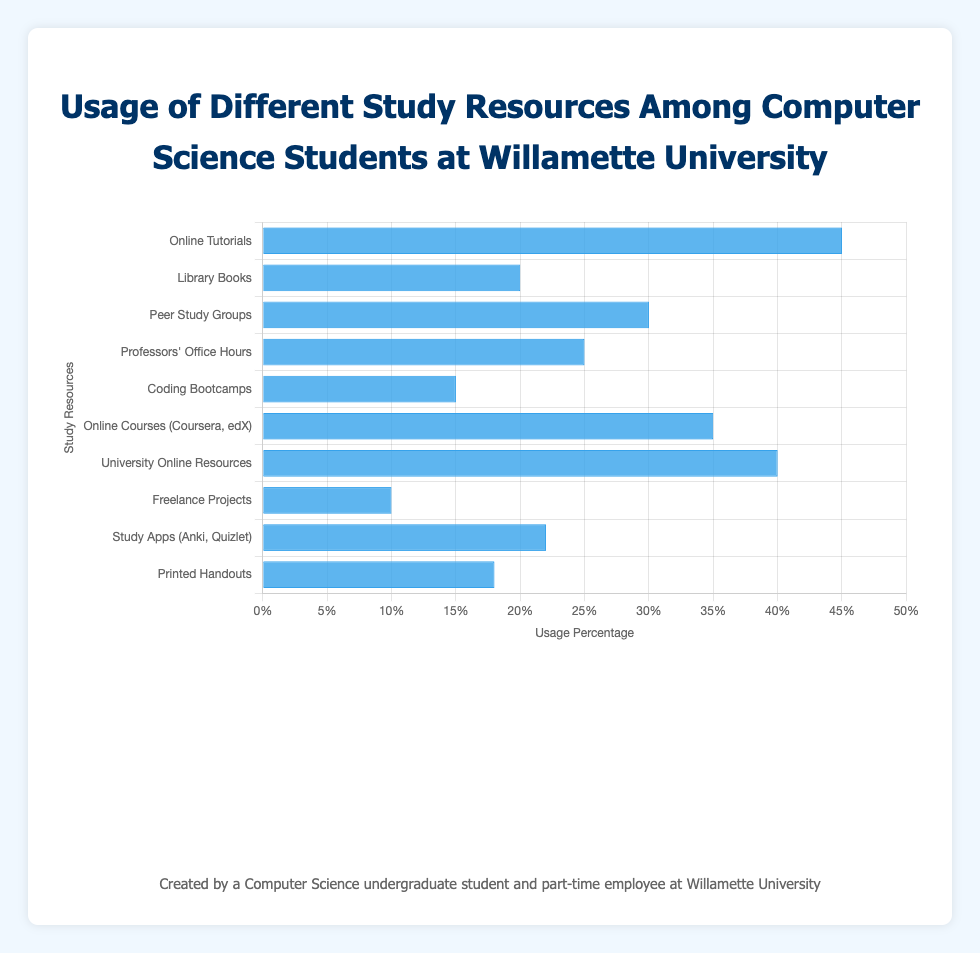What's the most frequently used study resource among Computer Science students according to the chart? The highest bar represents "Online Tutorials" with a usage percentage of 45%. It is the most frequently used study resource among students.
Answer: Online Tutorials Which study resource has the lowest usage percentage? The shortest bar represents "Freelance Projects" with a usage percentage of 10%. Therefore, it denotes the least utilized study resource.
Answer: Freelance Projects How much higher is the usage percentage of "Online Courses (Coursera, edX)" compared to "Coding Bootcamps"? To find this, subtract the usage percentage of "Coding Bootcamps" (15%) from "Online Courses (Coursera, edX)" (35%). The difference is 35% - 15% = 20%.
Answer: 20% What is the sum of the usage percentages for "Library Books" and "Professors' Office Hours"? Add the usage percentages of "Library Books" (20%) and "Professors' Office Hours" (25%). The total is 20% + 25% = 45%.
Answer: 45% Which is used more by students, "Peer Study Groups" or "University Online Resources (Blackboard, Moodle)"? And by how much? "Peer Study Groups" have a usage percentage of 30% and "University Online Resources" have 40%. The difference is 40% - 30% = 10%. Therefore, "University Online Resources" are used more by this amount.
Answer: University Online Resources by 10% Compare the usage percentages of "Study Apps (Anki, Quizlet)" and "Printed Handouts”. Which resource is used more and what is the percentage difference? The usage of "Study Apps (Anki, Quizlet)" is 22% and "Printed Handouts" is 18%. The difference is 22% - 18% = 4%. "Study Apps" are used more by 4%.
Answer: Study Apps by 4% What's the total usage percentage of all the resources combined? Sum the usage percentages of all the resources: 45% + 20% + 30% + 25% + 15% + 35% + 40% + 10% + 22% + 18% = 260%.
Answer: 260% Arrange the study resources in descending order of their usage percentages. From highest to lowest, the order is: Online Tutorials (45%), University Online Resources (40%), Online Courses (35%), Peer Study Groups (30%), Professors' Office Hours (25%), Study Apps (22%), Library Books (20%), Printed Handouts (18%), Coding Bootcamps (15%), Freelance Projects (10%).
Answer: Online Tutorials, University Online Resources, Online Courses, Peer Study Groups, Professors' Office Hours, Study Apps, Library Books, Printed Handouts, Coding Bootcamps, Freelance Projects What's the average usage percentage for the resources listed? Sum all percentages (260%) and divide by the number of resources (10). The average is 260% / 10 = 26%.
Answer: 26% 